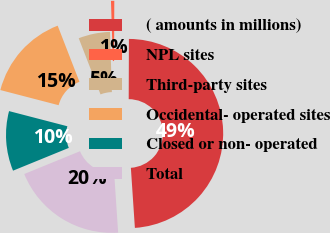<chart> <loc_0><loc_0><loc_500><loc_500><pie_chart><fcel>( amounts in millions)<fcel>NPL sites<fcel>Third-party sites<fcel>Occidental- operated sites<fcel>Closed or non- operated<fcel>Total<nl><fcel>48.88%<fcel>0.56%<fcel>5.39%<fcel>15.06%<fcel>10.22%<fcel>19.89%<nl></chart> 